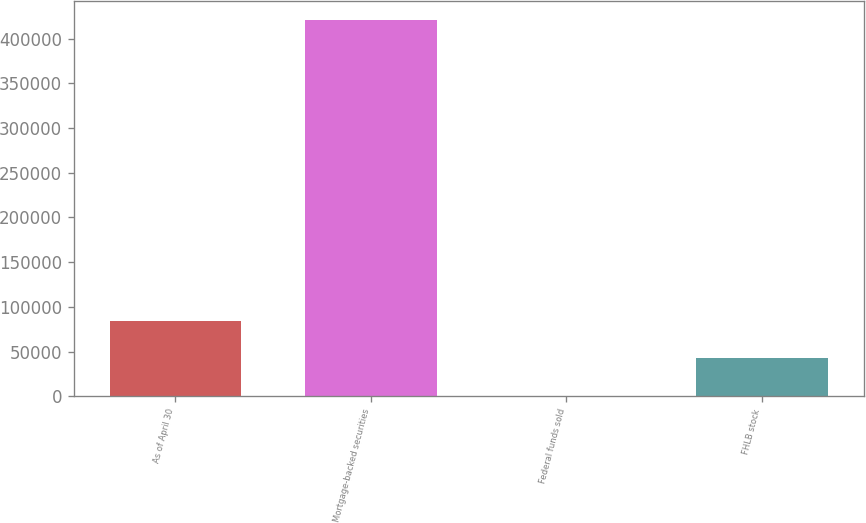Convert chart. <chart><loc_0><loc_0><loc_500><loc_500><bar_chart><fcel>As of April 30<fcel>Mortgage-backed securities<fcel>Federal funds sold<fcel>FHLB stock<nl><fcel>84415.8<fcel>421035<fcel>261<fcel>42338.4<nl></chart> 